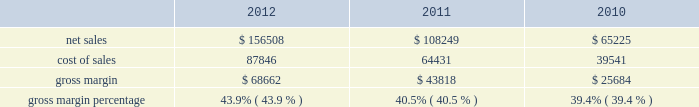$ 43.3 million in 2011 compared to $ 34.1 million in 2010 .
The retail segment represented 13% ( 13 % ) and 15% ( 15 % ) of the company 2019s total net sales in 2011 and 2010 , respectively .
The retail segment 2019s operating income was $ 4.7 billion , $ 3.2 billion , and $ 2.3 billion during 2012 , 2011 , and 2010 respectively .
These year-over-year increases in retail operating income were primarily attributable to higher overall net sales that resulted in significantly higher average revenue per store during the respective years .
Gross margin gross margin for 2012 , 2011 and 2010 are as follows ( in millions , except gross margin percentages ) : .
The gross margin percentage in 2012 was 43.9% ( 43.9 % ) , compared to 40.5% ( 40.5 % ) in 2011 .
This year-over-year increase in gross margin was largely driven by lower commodity and other product costs , a higher mix of iphone sales , and improved leverage on fixed costs from higher net sales .
The increase in gross margin was partially offset by the impact of a stronger u.s .
Dollar .
The gross margin percentage during the first half of 2012 was 45.9% ( 45.9 % ) compared to 41.4% ( 41.4 % ) during the second half of 2012 .
The primary drivers of higher gross margin in the first half of 2012 compared to the second half are a higher mix of iphone sales and improved leverage on fixed costs from higher net sales .
Additionally , gross margin in the second half of 2012 was also affected by the introduction of new products with flat pricing that have higher cost structures and deliver greater value to customers , price reductions on certain existing products , higher transition costs associated with product launches , and continued strengthening of the u.s .
Dollar ; partially offset by lower commodity costs .
The gross margin percentage in 2011 was 40.5% ( 40.5 % ) , compared to 39.4% ( 39.4 % ) in 2010 .
This year-over-year increase in gross margin was largely driven by lower commodity and other product costs .
The company expects to experience decreases in its gross margin percentage in future periods , as compared to levels achieved during 2012 , and the company anticipates gross margin of about 36% ( 36 % ) during the first quarter of 2013 .
Expected future declines in gross margin are largely due to a higher mix of new and innovative products with flat or reduced pricing that have higher cost structures and deliver greater value to customers and anticipated component cost and other cost increases .
Future strengthening of the u.s .
Dollar could further negatively impact gross margin .
The foregoing statements regarding the company 2019s expected gross margin percentage in future periods , including the first quarter of 2013 , are forward-looking and could differ from actual results because of several factors including , but not limited to those set forth above in part i , item 1a of this form 10-k under the heading 201crisk factors 201d and those described in this paragraph .
In general , gross margins and margins on individual products will remain under downward pressure due to a variety of factors , including continued industry wide global product pricing pressures , increased competition , compressed product life cycles , product transitions and potential increases in the cost of components , as well as potential increases in the costs of outside manufacturing services and a potential shift in the company 2019s sales mix towards products with lower gross margins .
In response to competitive pressures , the company expects it will continue to take product pricing actions , which would adversely affect gross margins .
Gross margins could also be affected by the company 2019s ability to manage product quality and warranty costs effectively and to stimulate demand for certain of its products .
Due to the company 2019s significant international operations , financial results can be significantly affected in the short-term by fluctuations in exchange rates. .
What was the percentage change in net sales from 2011 to 2012? 
Computations: ((156508 - 108249) / 108249)
Answer: 0.44581. 